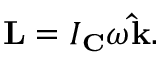Convert formula to latex. <formula><loc_0><loc_0><loc_500><loc_500>L = I _ { C } \omega \hat { k } .</formula> 